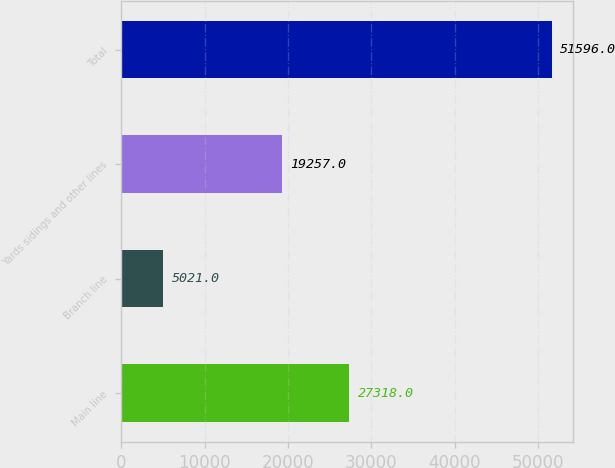Convert chart to OTSL. <chart><loc_0><loc_0><loc_500><loc_500><bar_chart><fcel>Main line<fcel>Branch line<fcel>Yards sidings and other lines<fcel>Total<nl><fcel>27318<fcel>5021<fcel>19257<fcel>51596<nl></chart> 